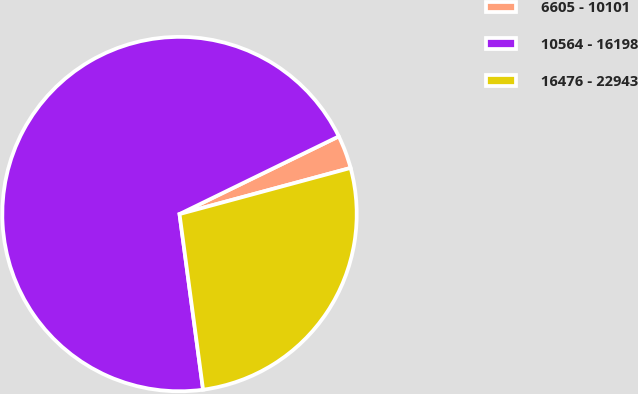<chart> <loc_0><loc_0><loc_500><loc_500><pie_chart><fcel>6605 - 10101<fcel>10564 - 16198<fcel>16476 - 22943<nl><fcel>3.03%<fcel>69.9%<fcel>27.07%<nl></chart> 